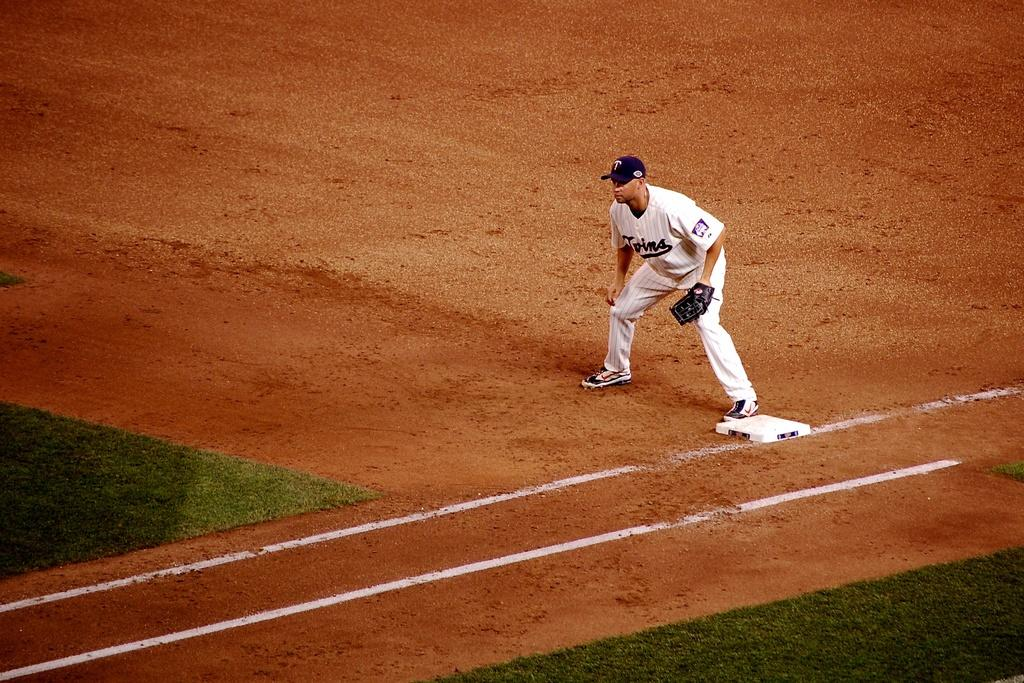What can be seen in the image? There is a person in the image. Can you describe the person's attire? The person is wearing a cap and a glove on his hand. What is the person standing on? The person is standing on the ground. What type of vegetation is visible in the image? There is grass visible in the image. What is the color of the white object in the image? The white object in the image is white. What are the white lines on the ground in the image? The white lines on the ground in the image are most likely markings or a path. What type of prose is the person reading in the image? There is no indication in the image that the person is reading any prose. Is there any lettuce visible in the image? No, there is no lettuce present in the image. 